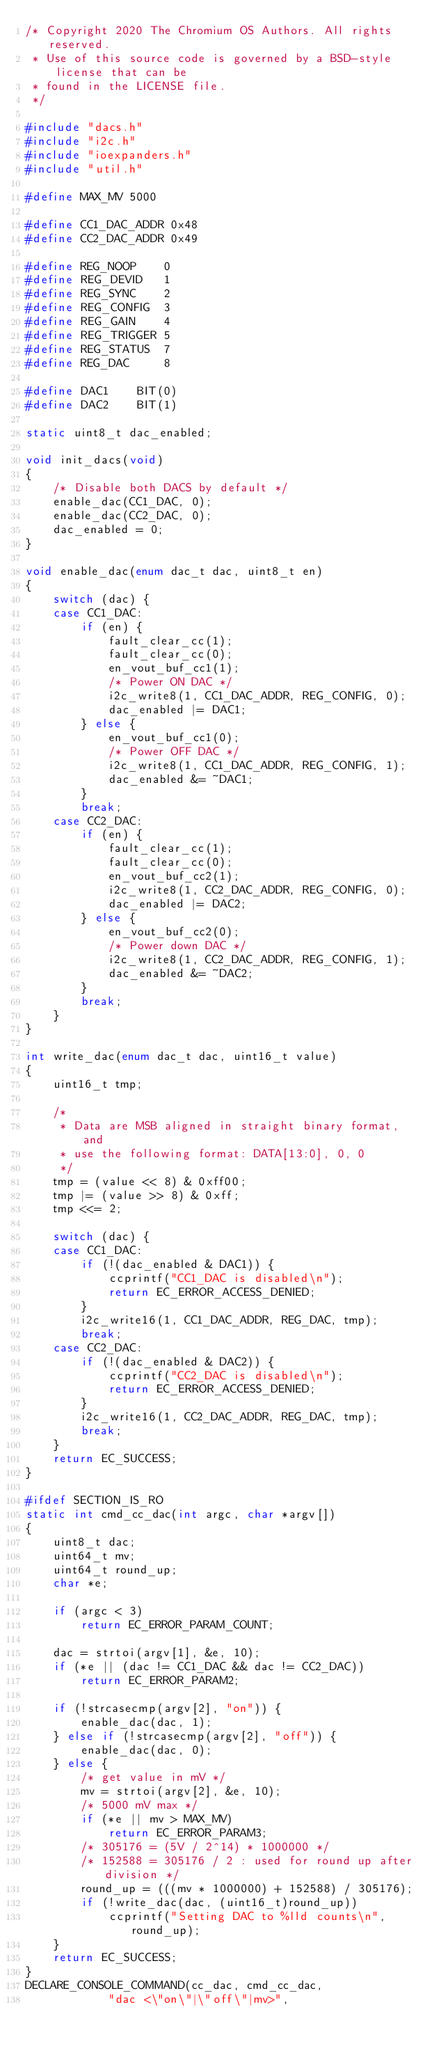<code> <loc_0><loc_0><loc_500><loc_500><_C_>/* Copyright 2020 The Chromium OS Authors. All rights reserved.
 * Use of this source code is governed by a BSD-style license that can be
 * found in the LICENSE file.
 */

#include "dacs.h"
#include "i2c.h"
#include "ioexpanders.h"
#include "util.h"

#define MAX_MV 5000

#define CC1_DAC_ADDR 0x48
#define CC2_DAC_ADDR 0x49

#define REG_NOOP    0
#define REG_DEVID   1
#define REG_SYNC    2
#define REG_CONFIG  3
#define REG_GAIN    4
#define REG_TRIGGER 5
#define REG_STATUS  7
#define REG_DAC     8

#define DAC1	BIT(0)
#define DAC2	BIT(1)

static uint8_t dac_enabled;

void init_dacs(void)
{
	/* Disable both DACS by default */
	enable_dac(CC1_DAC, 0);
	enable_dac(CC2_DAC, 0);
	dac_enabled = 0;
}

void enable_dac(enum dac_t dac, uint8_t en)
{
	switch (dac) {
	case CC1_DAC:
		if (en) {
			fault_clear_cc(1);
			fault_clear_cc(0);
			en_vout_buf_cc1(1);
			/* Power ON DAC */
			i2c_write8(1, CC1_DAC_ADDR, REG_CONFIG, 0);
			dac_enabled |= DAC1;
		} else {
			en_vout_buf_cc1(0);
			/* Power OFF DAC */
			i2c_write8(1, CC1_DAC_ADDR, REG_CONFIG, 1);
			dac_enabled &= ~DAC1;
		}
		break;
	case CC2_DAC:
		if (en) {
			fault_clear_cc(1);
			fault_clear_cc(0);
			en_vout_buf_cc2(1);
			i2c_write8(1, CC2_DAC_ADDR, REG_CONFIG, 0);
			dac_enabled |= DAC2;
		} else {
			en_vout_buf_cc2(0);
			/* Power down DAC */
			i2c_write8(1, CC2_DAC_ADDR, REG_CONFIG, 1);
			dac_enabled &= ~DAC2;
		}
		break;
	}
}

int write_dac(enum dac_t dac, uint16_t value)
{
	uint16_t tmp;

	/*
	 * Data are MSB aligned in straight binary format, and
	 * use the following format: DATA[13:0], 0, 0
	 */
	tmp = (value << 8) & 0xff00;
	tmp |= (value >> 8) & 0xff;
	tmp <<= 2;

	switch (dac) {
	case CC1_DAC:
		if (!(dac_enabled & DAC1)) {
			ccprintf("CC1_DAC is disabled\n");
			return EC_ERROR_ACCESS_DENIED;
		}
		i2c_write16(1, CC1_DAC_ADDR, REG_DAC, tmp);
		break;
	case CC2_DAC:
		if (!(dac_enabled & DAC2)) {
			ccprintf("CC2_DAC is disabled\n");
			return EC_ERROR_ACCESS_DENIED;
		}
		i2c_write16(1, CC2_DAC_ADDR, REG_DAC, tmp);
		break;
	}
	return EC_SUCCESS;
}

#ifdef SECTION_IS_RO
static int cmd_cc_dac(int argc, char *argv[])
{
	uint8_t dac;
	uint64_t mv;
	uint64_t round_up;
	char *e;

	if (argc < 3)
		return EC_ERROR_PARAM_COUNT;

	dac = strtoi(argv[1], &e, 10);
	if (*e || (dac != CC1_DAC && dac != CC2_DAC))
		return EC_ERROR_PARAM2;

	if (!strcasecmp(argv[2], "on")) {
		enable_dac(dac, 1);
	} else if (!strcasecmp(argv[2], "off")) {
		enable_dac(dac, 0);
	} else {
		/* get value in mV */
		mv = strtoi(argv[2], &e, 10);
		/* 5000 mV max */
		if (*e || mv > MAX_MV)
			return EC_ERROR_PARAM3;
		/* 305176 = (5V / 2^14) * 1000000 */
		/* 152588 = 305176 / 2 : used for round up after division */
		round_up = (((mv * 1000000) + 152588) / 305176);
		if (!write_dac(dac, (uint16_t)round_up))
			ccprintf("Setting DAC to %lld counts\n", round_up);
	}
	return EC_SUCCESS;
}
DECLARE_CONSOLE_COMMAND(cc_dac, cmd_cc_dac,
			"dac <\"on\"|\"off\"|mv>",</code> 